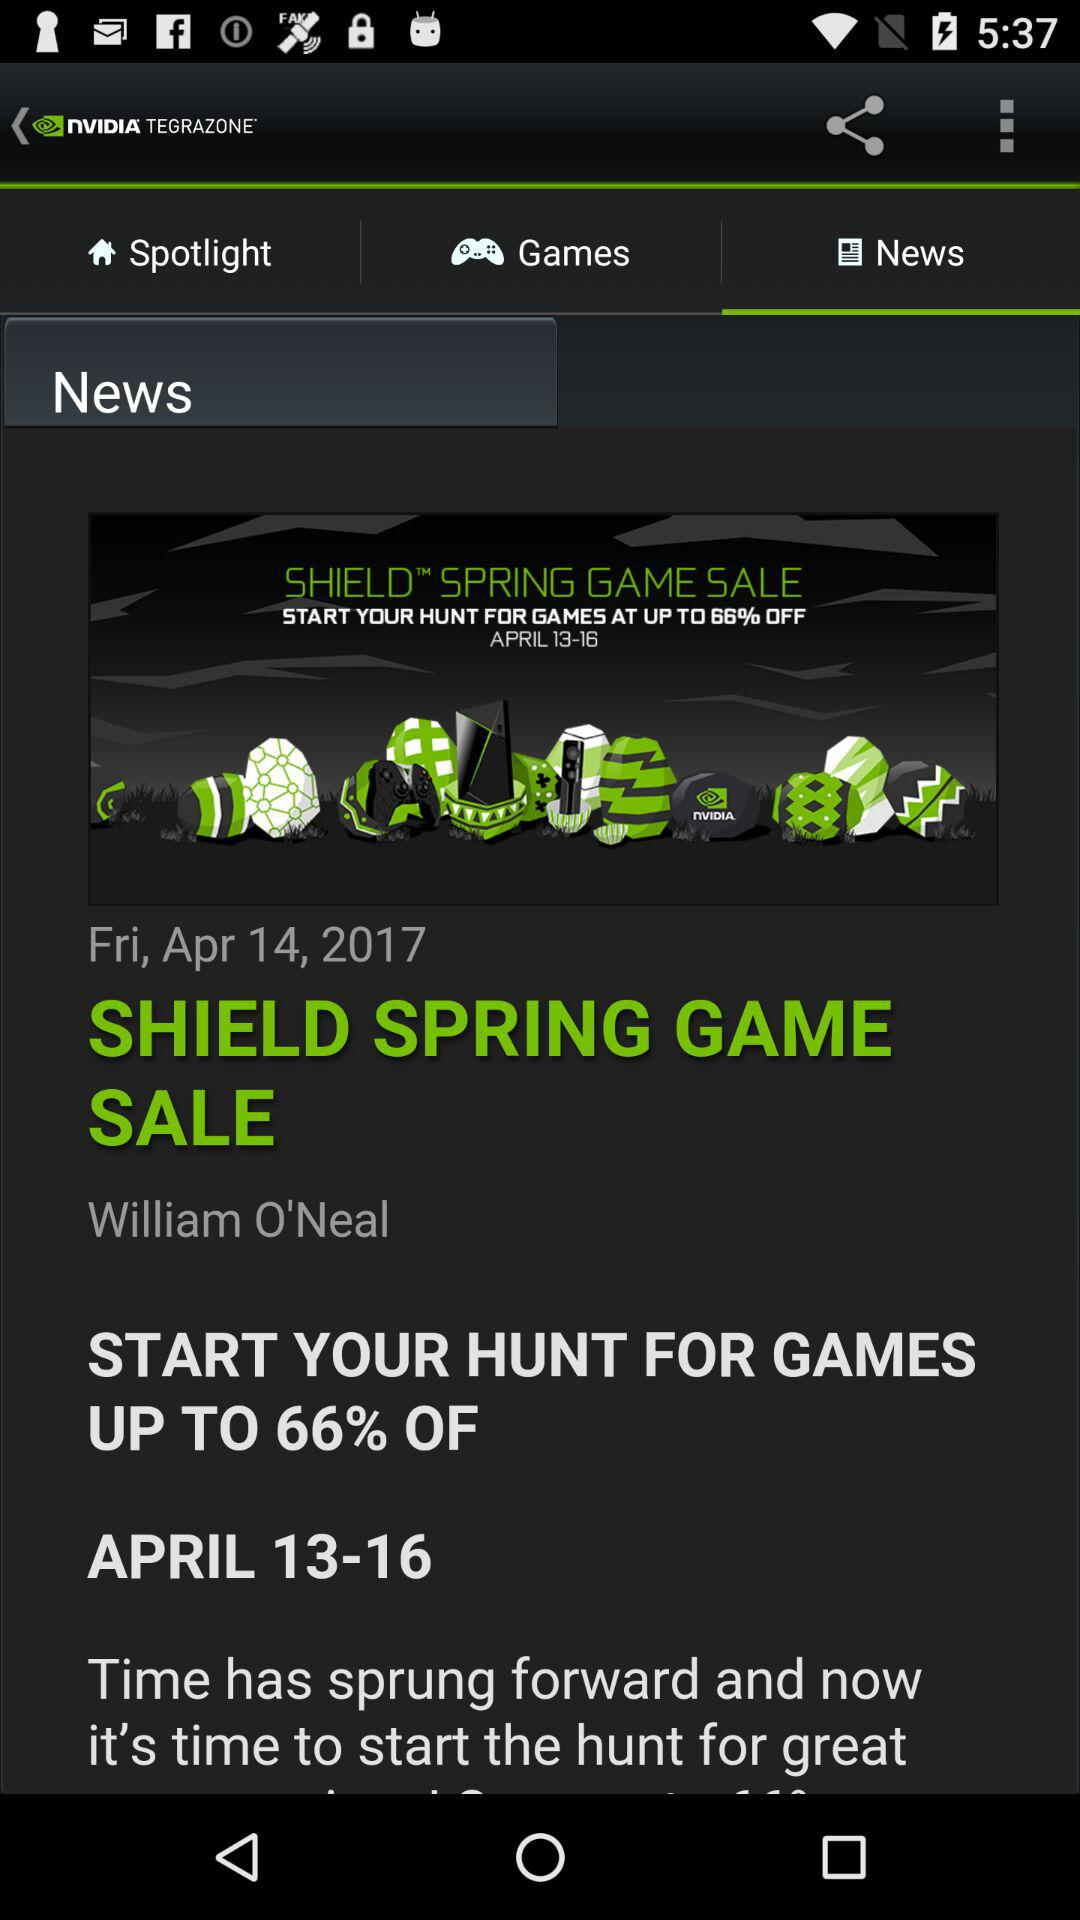What is the headline? The headline is "SHIELD SPRING GAME SALE". 